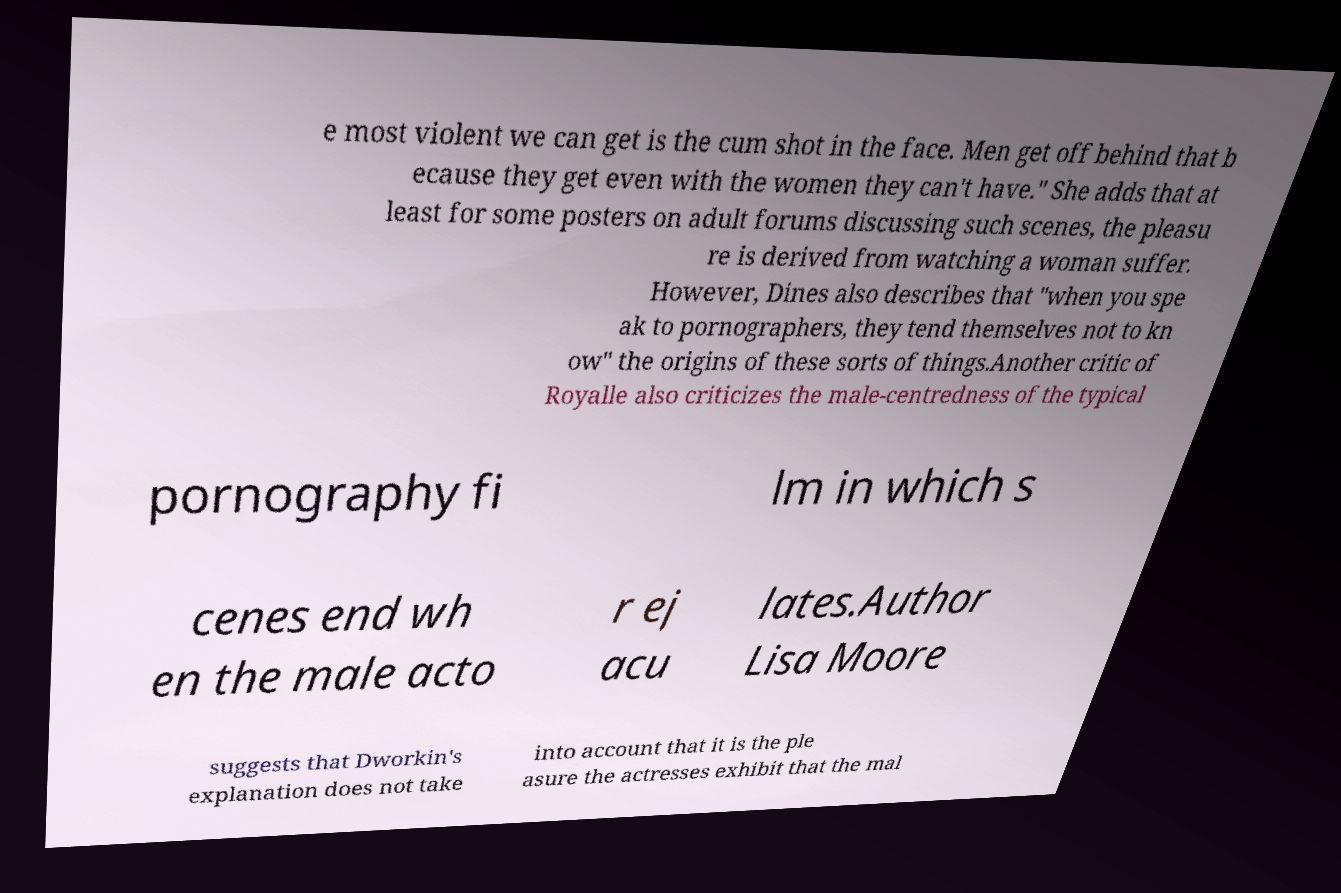Can you read and provide the text displayed in the image?This photo seems to have some interesting text. Can you extract and type it out for me? e most violent we can get is the cum shot in the face. Men get off behind that b ecause they get even with the women they can't have." She adds that at least for some posters on adult forums discussing such scenes, the pleasu re is derived from watching a woman suffer. However, Dines also describes that "when you spe ak to pornographers, they tend themselves not to kn ow" the origins of these sorts of things.Another critic of Royalle also criticizes the male-centredness of the typical pornography fi lm in which s cenes end wh en the male acto r ej acu lates.Author Lisa Moore suggests that Dworkin's explanation does not take into account that it is the ple asure the actresses exhibit that the mal 